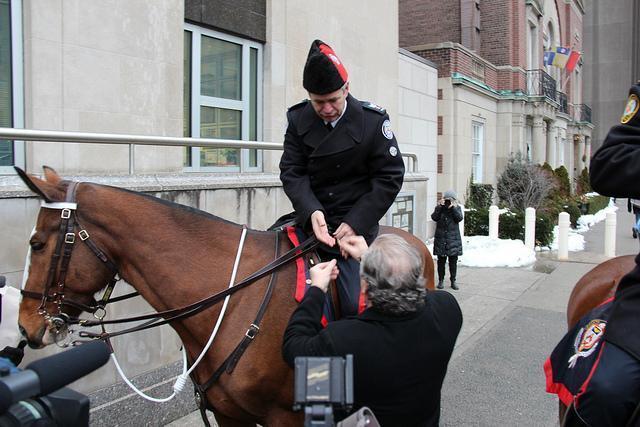How many horses are there?
Give a very brief answer. 2. How many people are in the picture?
Give a very brief answer. 3. 